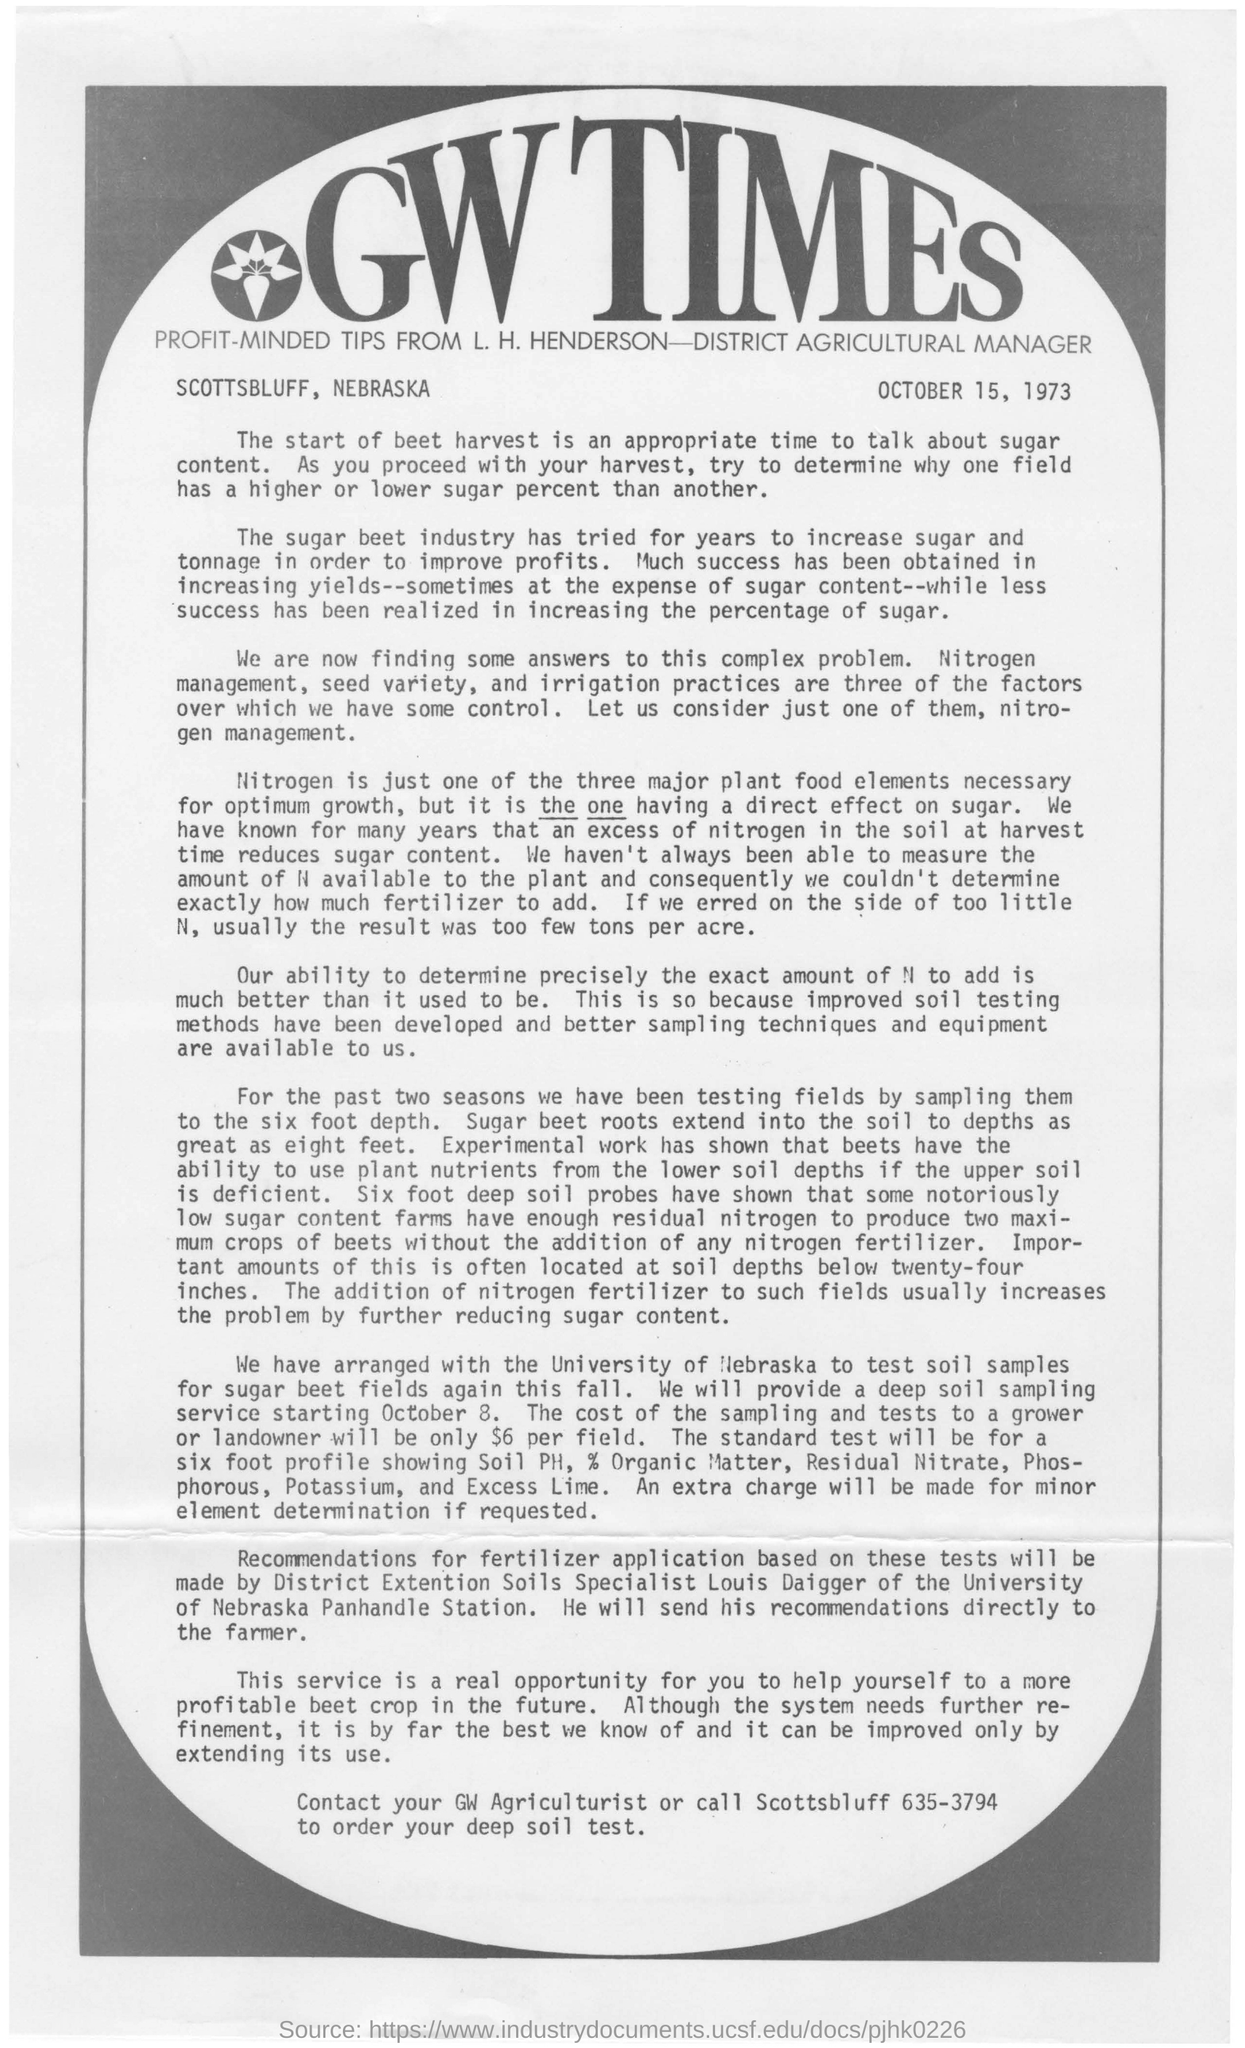Point out several critical features in this image. The phrase 'GW TIMES' is written in large, ornate letters at the top of the document. Excessive nitrogen in the soil at harvest time can lead to a reduction in sugar content in crops. The date "October 15, 1973" is mentioned on the page at the top right. The cost of sampling and testing for growers or landowners is $6 per field. The most crucial plant food elements required for optimal growth are nitrogen. 